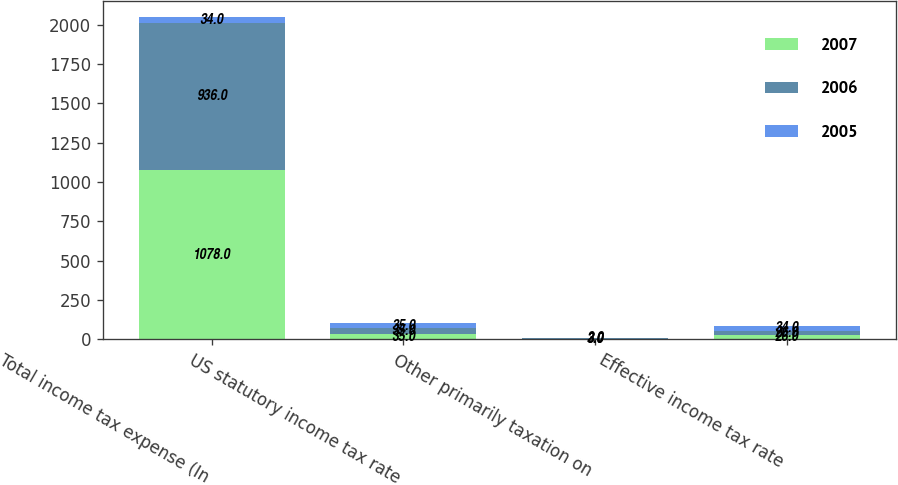<chart> <loc_0><loc_0><loc_500><loc_500><stacked_bar_chart><ecel><fcel>Total income tax expense (In<fcel>US statutory income tax rate<fcel>Other primarily taxation on<fcel>Effective income tax rate<nl><fcel>2007<fcel>1078<fcel>35<fcel>3<fcel>26<nl><fcel>2006<fcel>936<fcel>35<fcel>3<fcel>26<nl><fcel>2005<fcel>34<fcel>35<fcel>2<fcel>34<nl></chart> 